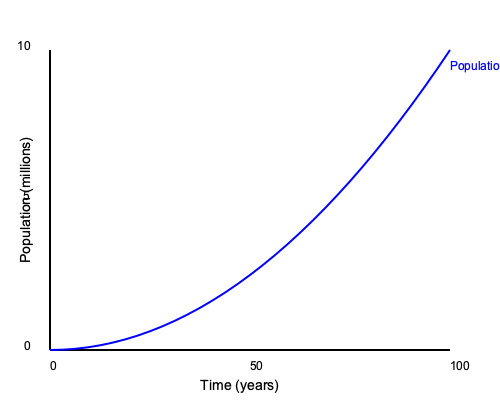In our latest podcast episode, we discussed exponential population growth. Looking at this graph, what can you infer about the rate of population growth over time? How does this relate to the concept of carrying capacity we joked about? To interpret this graph and understand its relation to carrying capacity, let's break it down step-by-step:

1. Shape of the curve: The line on the graph is curved upward, indicating exponential growth. This means the population is growing at an increasing rate over time.

2. Initial growth: At the beginning (left side of the graph), the population grows slowly.

3. Accelerating growth: As time progresses (moving right on the x-axis), the curve becomes steeper, showing that the population is growing faster.

4. Rate of change: The rate of growth is not constant. It increases over time, which is a key characteristic of exponential growth.

5. Carrying capacity: In the podcast, we joked about carrying capacity, which is the maximum population size that an environment can sustain indefinitely. This graph doesn't show a carrying capacity being reached, as the line continues to rise without leveling off.

6. Real-world implications: If this were a real population, we'd expect the growth to eventually slow down as resources become limited. The absence of this slowdown in the graph suggests we're looking at a theoretical model or a population that hasn't yet reached its environmental limits.

7. Time frame: The x-axis shows 100 years, indicating this is a long-term population trend.

In reality, populations can't grow exponentially forever due to limited resources, which is where the concept of carrying capacity becomes important. This graph shows an idealized exponential growth scenario, which is often used as a starting point for understanding population dynamics before factoring in real-world limitations.
Answer: The population grows at an increasing rate over time, demonstrating exponential growth without reaching a carrying capacity. 